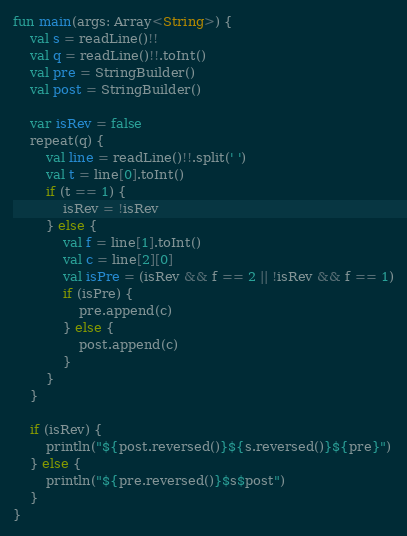Convert code to text. <code><loc_0><loc_0><loc_500><loc_500><_Kotlin_>fun main(args: Array<String>) {
    val s = readLine()!!
    val q = readLine()!!.toInt()
    val pre = StringBuilder()
    val post = StringBuilder()

    var isRev = false
    repeat(q) {
        val line = readLine()!!.split(' ')
        val t = line[0].toInt()
        if (t == 1) {
            isRev = !isRev
        } else {
            val f = line[1].toInt()
            val c = line[2][0]
            val isPre = (isRev && f == 2 || !isRev && f == 1)
            if (isPre) {
                pre.append(c)
            } else {
                post.append(c)
            }
        }
    }

    if (isRev) {
        println("${post.reversed()}${s.reversed()}${pre}")
    } else {
        println("${pre.reversed()}$s$post")
    }
}</code> 